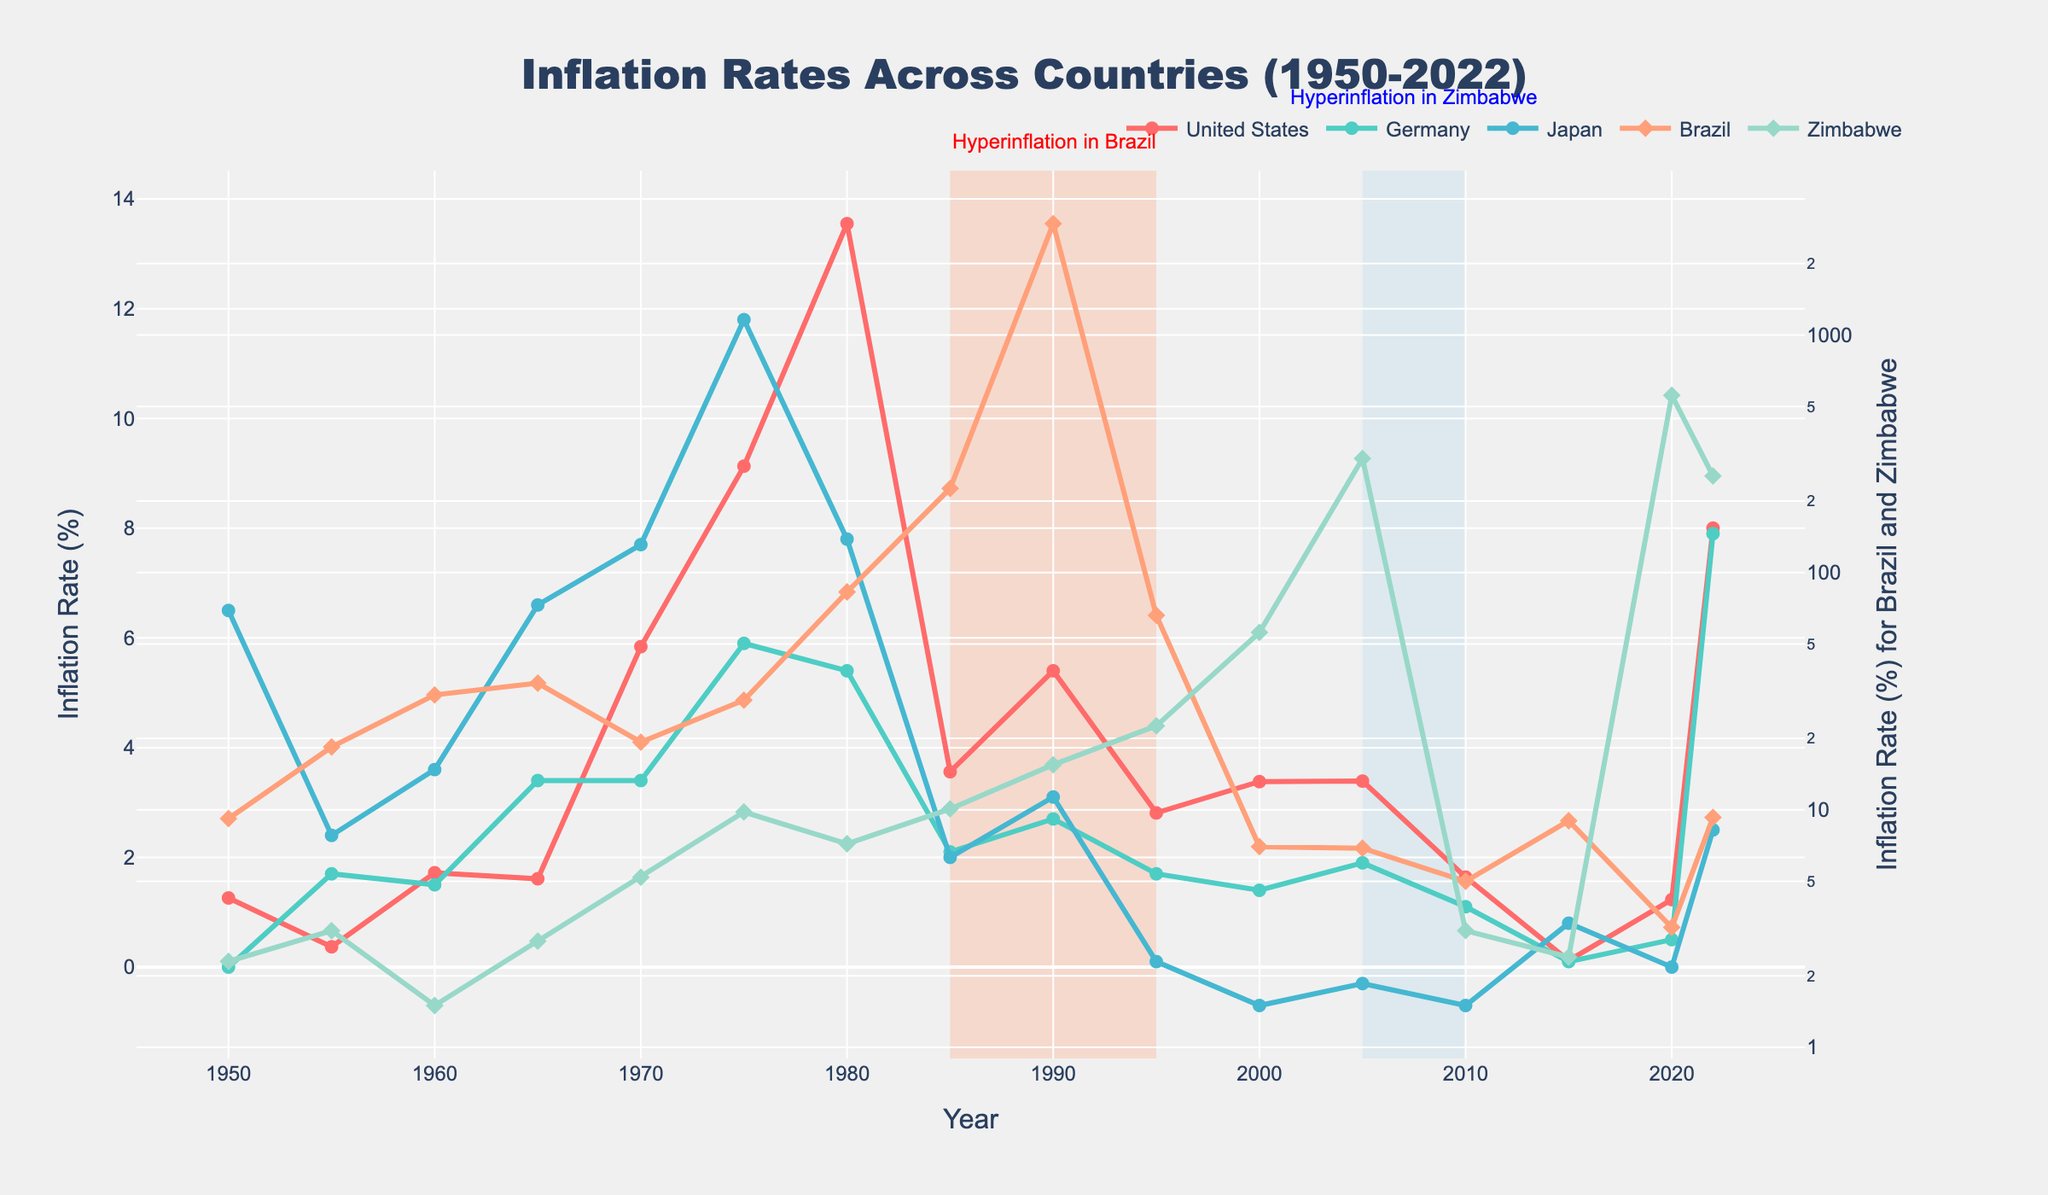What is the inflation rate for the United States in the year 2022? Locate the year 2022 on the x-axis and follow the line for the United States. The inflation rate in 2022 is marked as 8.00%
Answer: 8.00% In which year did Japan experience a negative inflation rate (deflation), and what was the value? Observe the line for Japan and find the year where the inflation rate dips below zero. The years are 2000 and 2010 with values at -0.70%.
Answer: 2000, 2010, -0.70% How does the inflation rate of Germany in 1975 compare to that of the United States in the same year? Locate the year 1975 on the x-axis and compare the inflation rates for Germany and the United States. Germany's rate is 5.90%, and the United States is 9.13%.
Answer: United States: 9.13%, Germany: 5.90% What was the average inflation rate for Brazil between the years 1985 and 1990? Identify the inflation rates for Brazil in 1985 (226.00%) and 1990 (2947.70%), add them up (226 + 2947.7 = 3173.7), and divide by 2 for the average: 3173.7/2 = 1586.85%
Answer: 1586.85% What country had the highest inflation rate in the year 2000, and what was the rate? Locate the year 2000 on the x-axis and compare the inflation rates for all countries. Zimbabwe had the highest at 55.90%.
Answer: Zimbabwe, 55.90% During which period did Zimbabwe experience hyperinflation according to the shaded area? Look for the shaded rectangular area on the figure. It indicates Zimbabwe experienced hyperinflation between 2005 and 2010.
Answer: 2005-2010 Which countries have experienced a decline in inflation rate in the year 2020 compared to 2000? Compare the inflation rates for 2000 and 2020 for each country. Only Brazil shows a decline from 7.00% in 2000 to 3.20% in 2020.
Answer: Brazil What is the overall trend of the inflation rate in the United States from 1950 to 2022? Observe the line for the United States over the entire time period. There is variability but generally higher peaks in the 1970s and 1980s with a recent rise in 2022.
Answer: Variable, high peaks in 1970s-1980s, recent rise in 2022 Which country had the lowest inflation rate in the year 2015 and what was the rate? Locate 2015 on the x-axis and compare the rates for all countries. Germany had the lowest rate at 0.10%.
Answer: Germany, 0.10% 